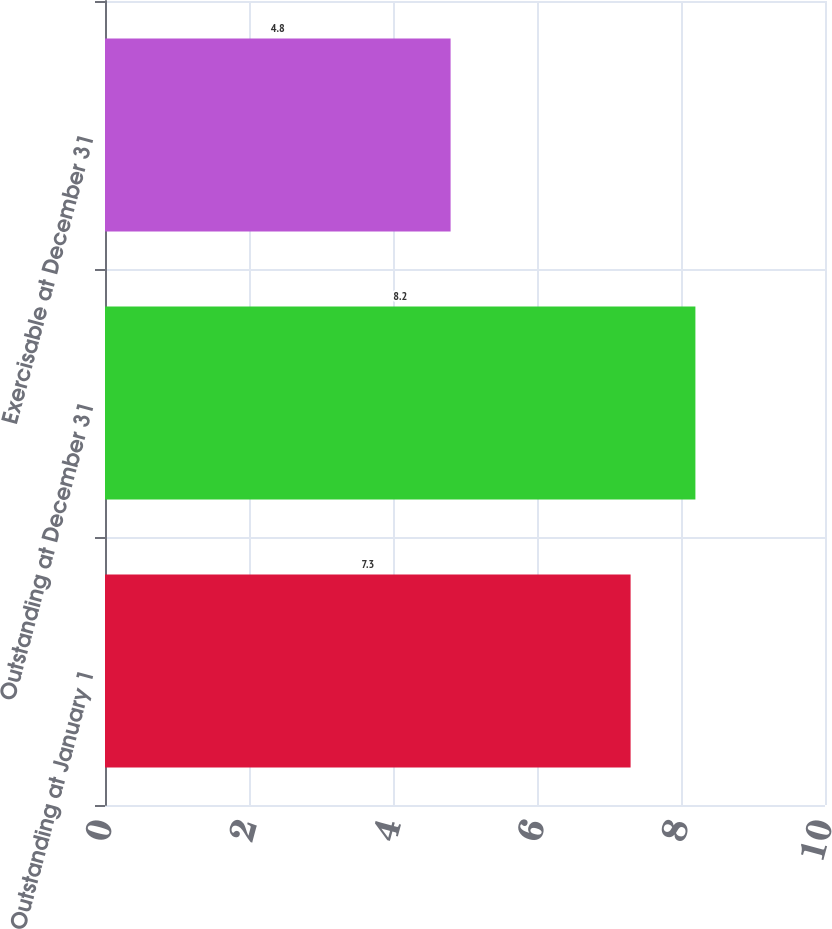<chart> <loc_0><loc_0><loc_500><loc_500><bar_chart><fcel>Outstanding at January 1<fcel>Outstanding at December 31<fcel>Exercisable at December 31<nl><fcel>7.3<fcel>8.2<fcel>4.8<nl></chart> 